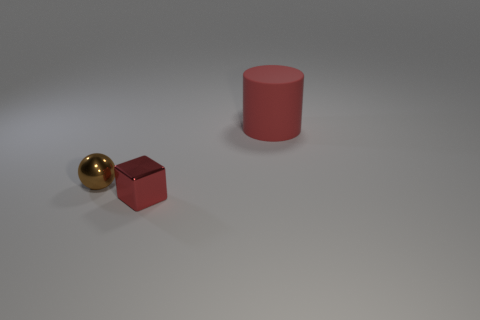What is the color of the small ball that is the same material as the red block?
Provide a short and direct response. Brown. What number of rubber objects are blue objects or brown things?
Ensure brevity in your answer.  0. There is a thing that is the same size as the brown ball; what is its shape?
Make the answer very short. Cube. What number of objects are objects on the left side of the cylinder or objects that are to the right of the tiny red shiny cube?
Your response must be concise. 3. There is a ball that is the same size as the block; what is it made of?
Offer a terse response. Metal. How many other objects are there of the same material as the big cylinder?
Offer a terse response. 0. Are there the same number of small brown things to the left of the big red cylinder and big rubber things that are to the left of the small red cube?
Give a very brief answer. No. How many green things are either small shiny blocks or big cylinders?
Give a very brief answer. 0. There is a large thing; is its color the same as the small metal object that is in front of the brown ball?
Your answer should be compact. Yes. How many other objects are there of the same color as the big matte thing?
Keep it short and to the point. 1. 